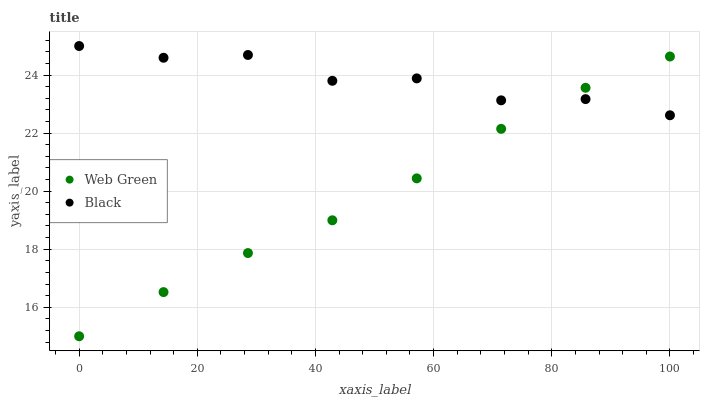Does Web Green have the minimum area under the curve?
Answer yes or no. Yes. Does Black have the maximum area under the curve?
Answer yes or no. Yes. Does Web Green have the maximum area under the curve?
Answer yes or no. No. Is Web Green the smoothest?
Answer yes or no. Yes. Is Black the roughest?
Answer yes or no. Yes. Is Web Green the roughest?
Answer yes or no. No. Does Web Green have the lowest value?
Answer yes or no. Yes. Does Black have the highest value?
Answer yes or no. Yes. Does Web Green have the highest value?
Answer yes or no. No. Does Black intersect Web Green?
Answer yes or no. Yes. Is Black less than Web Green?
Answer yes or no. No. Is Black greater than Web Green?
Answer yes or no. No. 